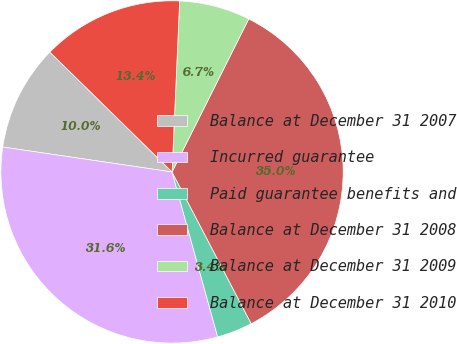Convert chart to OTSL. <chart><loc_0><loc_0><loc_500><loc_500><pie_chart><fcel>Balance at December 31 2007<fcel>Incurred guarantee<fcel>Paid guarantee benefits and<fcel>Balance at December 31 2008<fcel>Balance at December 31 2009<fcel>Balance at December 31 2010<nl><fcel>10.02%<fcel>31.62%<fcel>3.36%<fcel>34.95%<fcel>6.69%<fcel>13.36%<nl></chart> 